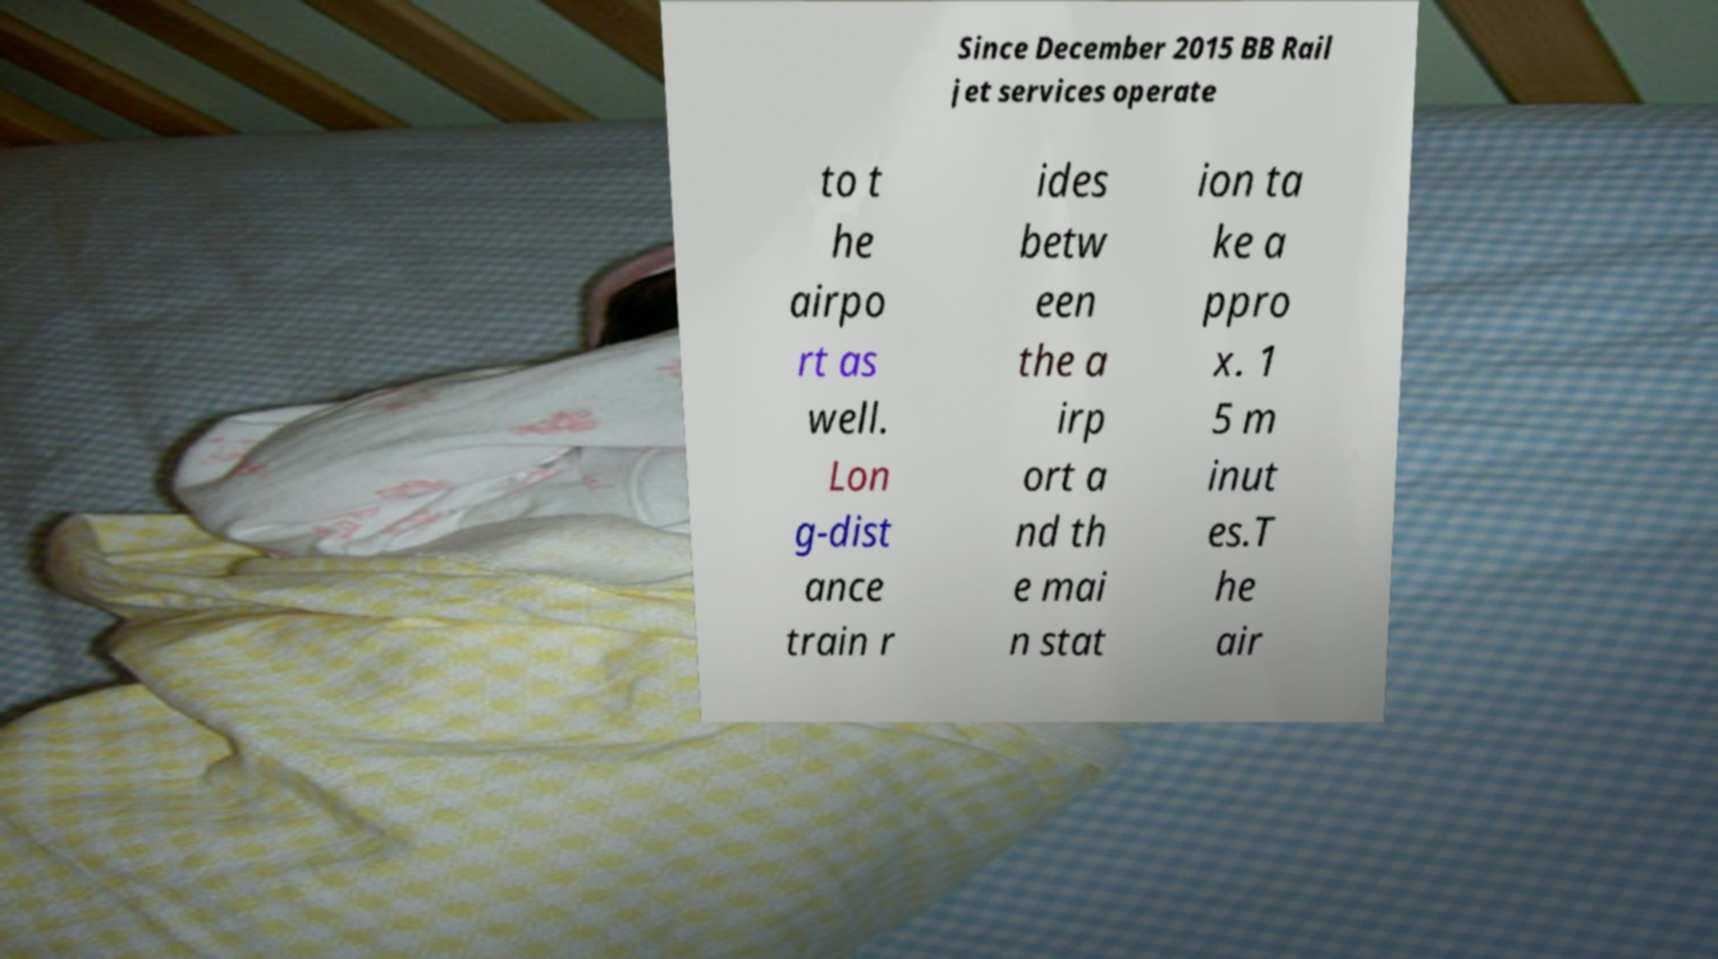Please read and relay the text visible in this image. What does it say? Since December 2015 BB Rail jet services operate to t he airpo rt as well. Lon g-dist ance train r ides betw een the a irp ort a nd th e mai n stat ion ta ke a ppro x. 1 5 m inut es.T he air 